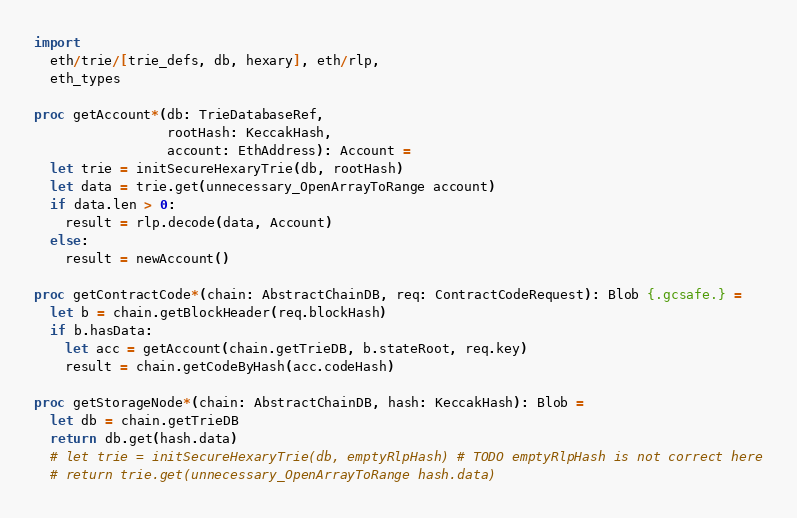<code> <loc_0><loc_0><loc_500><loc_500><_Nim_>import
  eth/trie/[trie_defs, db, hexary], eth/rlp,
  eth_types

proc getAccount*(db: TrieDatabaseRef,
                 rootHash: KeccakHash,
                 account: EthAddress): Account =
  let trie = initSecureHexaryTrie(db, rootHash)
  let data = trie.get(unnecessary_OpenArrayToRange account)
  if data.len > 0:
    result = rlp.decode(data, Account)
  else:
    result = newAccount()

proc getContractCode*(chain: AbstractChainDB, req: ContractCodeRequest): Blob {.gcsafe.} =
  let b = chain.getBlockHeader(req.blockHash)
  if b.hasData:
    let acc = getAccount(chain.getTrieDB, b.stateRoot, req.key)
    result = chain.getCodeByHash(acc.codeHash)

proc getStorageNode*(chain: AbstractChainDB, hash: KeccakHash): Blob =
  let db = chain.getTrieDB
  return db.get(hash.data)
  # let trie = initSecureHexaryTrie(db, emptyRlpHash) # TODO emptyRlpHash is not correct here
  # return trie.get(unnecessary_OpenArrayToRange hash.data)

</code> 